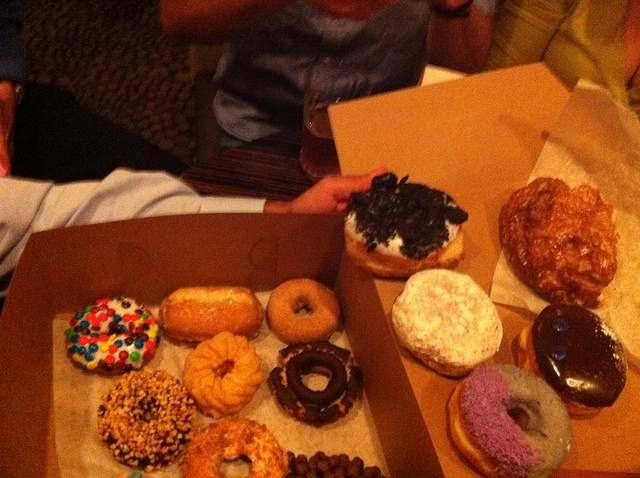Describe the objects in this image and their specific colors. I can see people in black, maroon, and brown tones, people in black, tan, maroon, and gray tones, donut in black, brown, red, and maroon tones, donut in black, brown, and maroon tones, and donut in black, maroon, and brown tones in this image. 